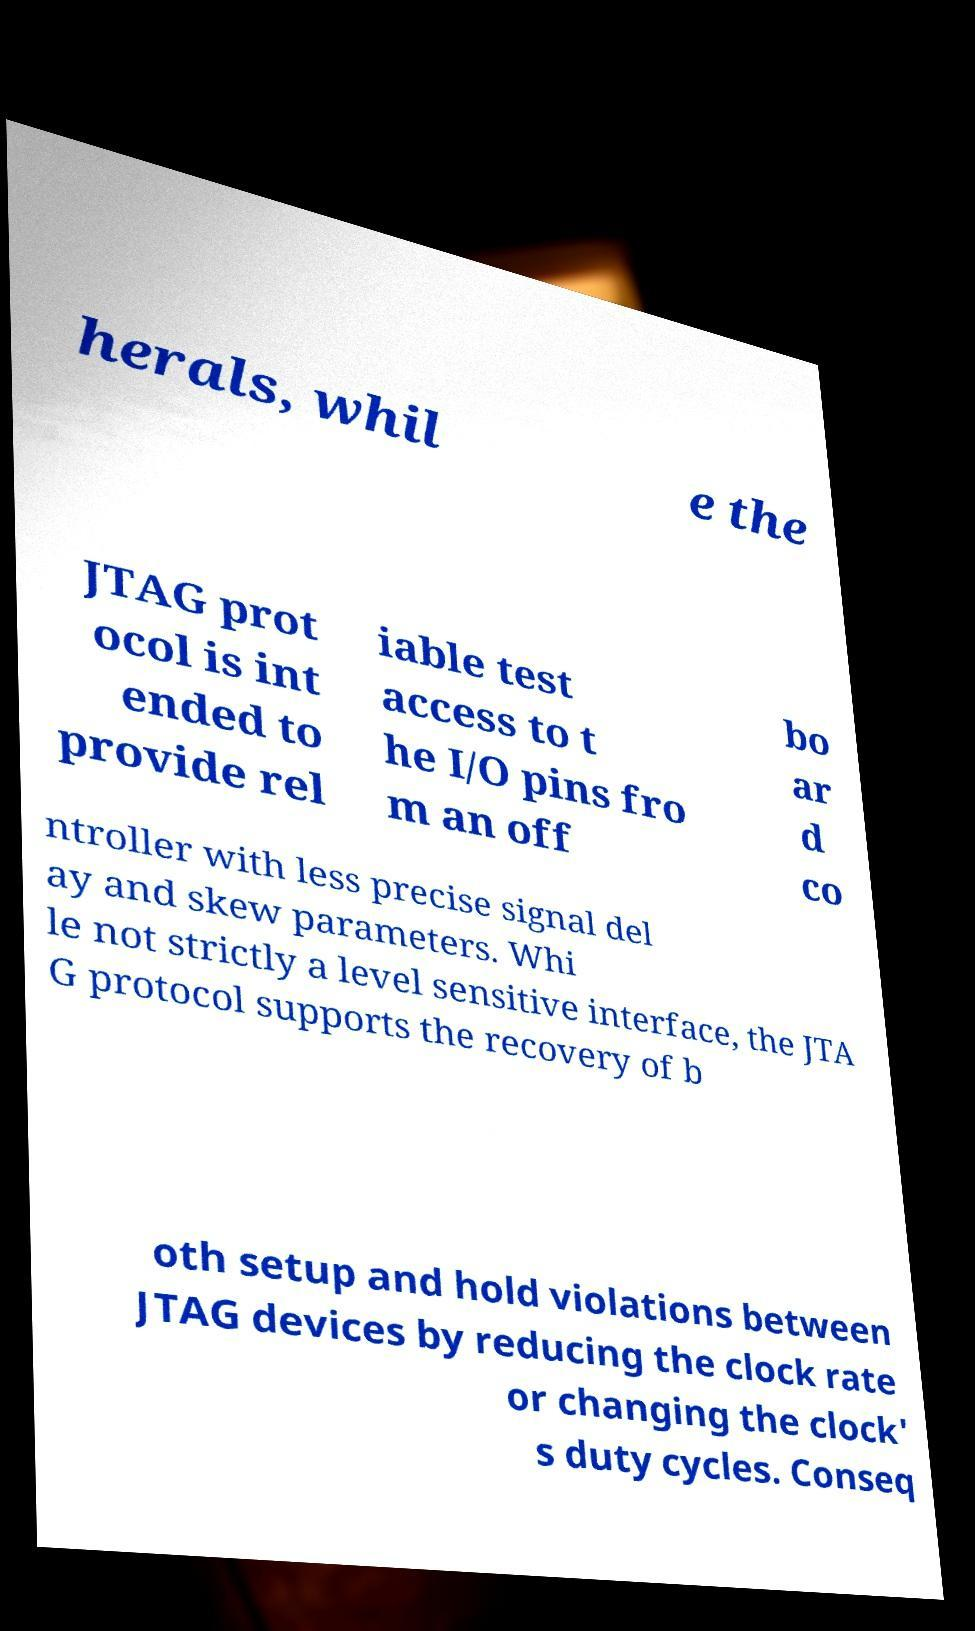Please identify and transcribe the text found in this image. herals, whil e the JTAG prot ocol is int ended to provide rel iable test access to t he I/O pins fro m an off bo ar d co ntroller with less precise signal del ay and skew parameters. Whi le not strictly a level sensitive interface, the JTA G protocol supports the recovery of b oth setup and hold violations between JTAG devices by reducing the clock rate or changing the clock' s duty cycles. Conseq 